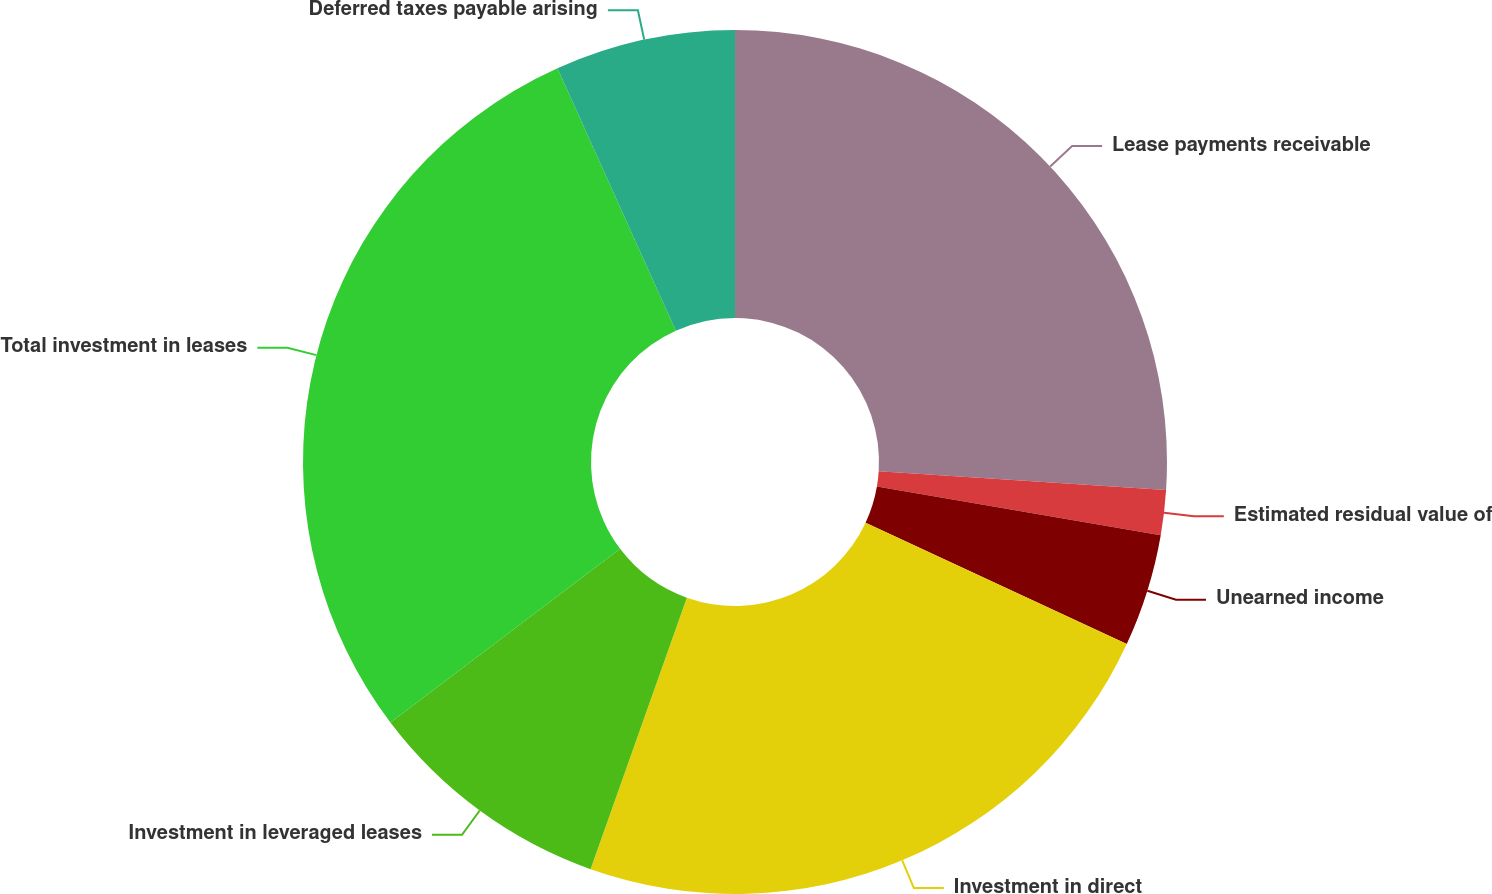<chart> <loc_0><loc_0><loc_500><loc_500><pie_chart><fcel>Lease payments receivable<fcel>Estimated residual value of<fcel>Unearned income<fcel>Investment in direct<fcel>Investment in leveraged leases<fcel>Total investment in leases<fcel>Deferred taxes payable arising<nl><fcel>26.03%<fcel>1.68%<fcel>4.21%<fcel>23.5%<fcel>9.27%<fcel>28.56%<fcel>6.74%<nl></chart> 